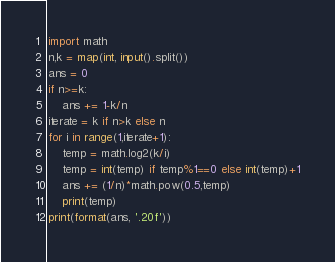<code> <loc_0><loc_0><loc_500><loc_500><_Python_>import math
n,k = map(int, input().split())
ans = 0
if n>=k:
    ans += 1-k/n
iterate = k if n>k else n
for i in range(1,iterate+1):
    temp = math.log2(k/i)
    temp = int(temp) if temp%1==0 else int(temp)+1
    ans += (1/n)*math.pow(0.5,temp)
    print(temp)
print(format(ans, '.20f'))</code> 